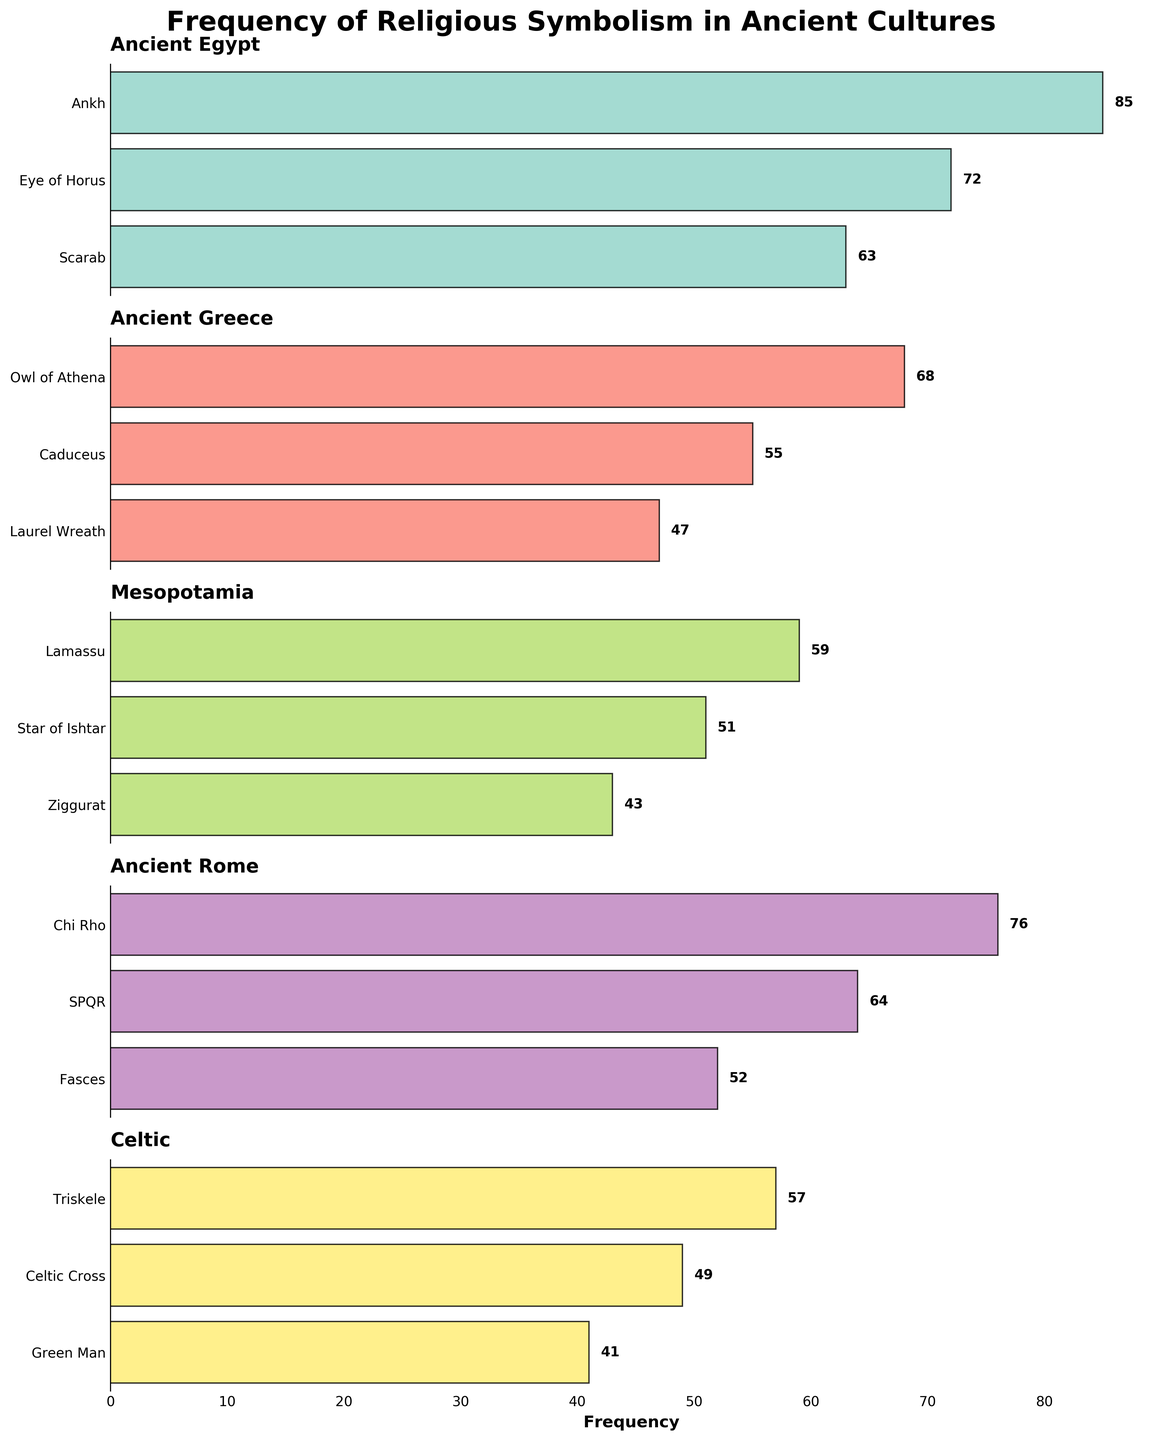What is the title of the plot? The title is located at the top of the figure and provides an overview of what the figure represents.
Answer: Frequency of Religious Symbolism in Ancient Cultures What is the total number of symbols represented for Ancient Egypt and Ancient Greece combined? First, count the number of symbols for Ancient Egypt (3) and for Ancient Greece (3). Add these counts together: 3 + 3 = 6.
Answer: 6 Which culture has the symbol with the highest frequency? The highest frequency in the entire plot is 85, and this corresponds to the Ankh symbol for Ancient Egypt.
Answer: Ancient Egypt How many more symbols does Ancient Rome have compared to Mesopotamia? Count the number of symbols for Ancient Rome (3) and Mesopotamia (3). The difference is 3 - 3 = 0.
Answer: 0 What is the difference in frequency between the Ankh and the Eye of Horus symbols in Ancient Egypt? The frequency of the Ankh is 85 and the Eye of Horus is 72. Subtract 72 from 85: 85 - 72 = 13.
Answer: 13 Which culture has the lowest frequency symbol, and what is the symbol? The lowest frequency in the entire plot is 41 for the Green Man symbol in the Celtic culture.
Answer: Celtic, Green Man What is the average frequency of the symbols in Ancient Rome? Add the frequencies of the symbols in Ancient Rome (76, 64, 52) and divide by the number of symbols (3): (76 + 64 + 52) / 3 = 64.
Answer: 64 Which symbol has a higher frequency, the Owl of Athena or the Caduceus in Ancient Greece? Compare the frequencies: Owl of Athena (68), Caduceus (55). Since 68 > 55, the Owl of Athena has a higher frequency.
Answer: Owl of Athena How many symbols have a frequency greater than 60? Count the symbols with frequencies greater than 60: Ankh (85), Eye of Horus (72), Scarab (63), Owl of Athena (68), Chi Rho (76), SPQR (64). There are 6 such symbols.
Answer: 6 What is the frequency range (difference between highest and lowest frequency) across all symbols? Find the highest frequency (85) and the lowest frequency (41). Subtract the lowest from the highest: 85 - 41 = 44.
Answer: 44 